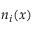<formula> <loc_0><loc_0><loc_500><loc_500>n _ { i } ( x )</formula> 